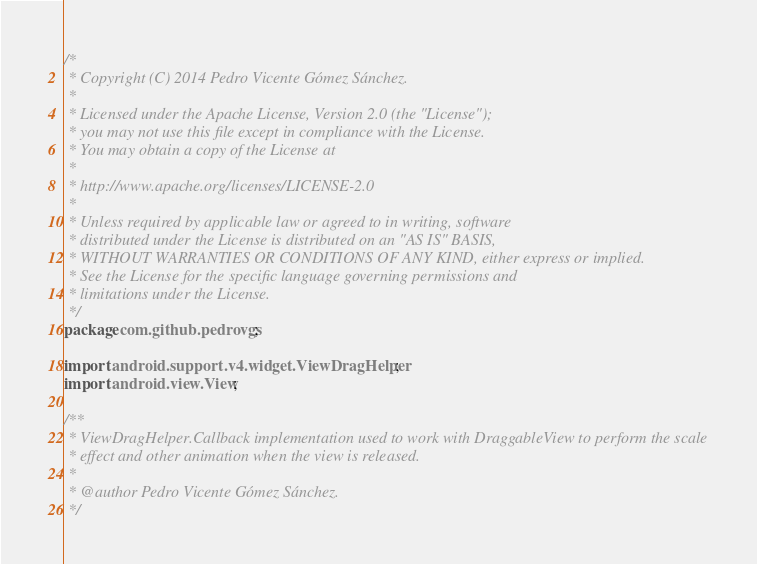Convert code to text. <code><loc_0><loc_0><loc_500><loc_500><_Java_>/*
 * Copyright (C) 2014 Pedro Vicente Gómez Sánchez.
 *
 * Licensed under the Apache License, Version 2.0 (the "License");
 * you may not use this file except in compliance with the License.
 * You may obtain a copy of the License at
 *
 * http://www.apache.org/licenses/LICENSE-2.0
 *
 * Unless required by applicable law or agreed to in writing, software
 * distributed under the License is distributed on an "AS IS" BASIS,
 * WITHOUT WARRANTIES OR CONDITIONS OF ANY KIND, either express or implied.
 * See the License for the specific language governing permissions and
 * limitations under the License.
 */
package com.github.pedrovgs;

import android.support.v4.widget.ViewDragHelper;
import android.view.View;

/**
 * ViewDragHelper.Callback implementation used to work with DraggableView to perform the scale
 * effect and other animation when the view is released.
 *
 * @author Pedro Vicente Gómez Sánchez.
 */</code> 